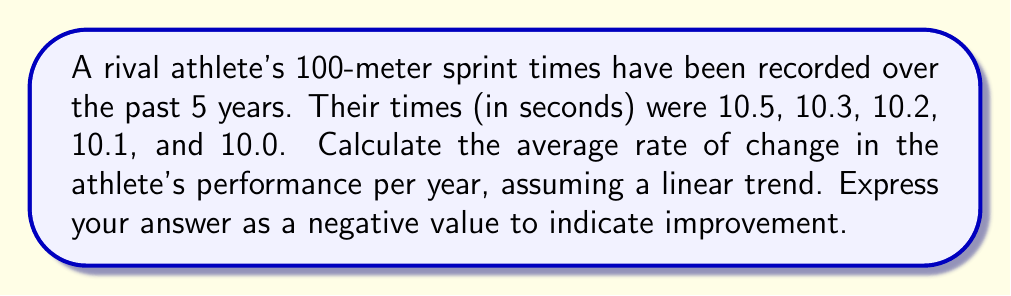Can you solve this math problem? To calculate the average rate of change, we'll use the formula:

$$ \text{Average rate of change} = \frac{\text{Change in y}}{\text{Change in x}} $$

1) First, let's identify our points:
   $(x_1, y_1) = (0, 10.5)$ (initial year, initial time)
   $(x_2, y_2) = (4, 10.0)$ (4 years later, final time)

2) Now, let's calculate the change in y (time):
   $\Delta y = y_2 - y_1 = 10.0 - 10.5 = -0.5$ seconds

3) The change in x (years) is:
   $\Delta x = x_2 - x_1 = 4 - 0 = 4$ years

4) Applying the formula:
   $$ \text{Average rate of change} = \frac{-0.5 \text{ seconds}}{4 \text{ years}} = -0.125 \text{ seconds/year} $$

5) The negative value indicates an improvement (decrease) in time.
Answer: $-0.125$ seconds/year 